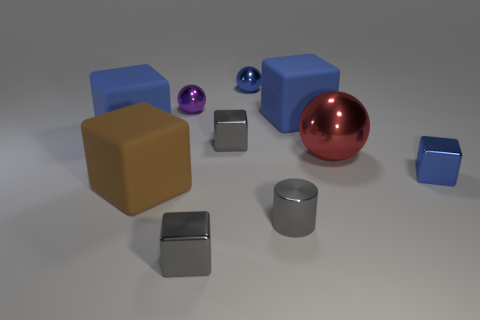Subtract all gray cubes. How many cubes are left? 4 Subtract all cylinders. How many objects are left? 9 Subtract all blue cubes. How many cubes are left? 3 Subtract all red shiny objects. Subtract all tiny metal blocks. How many objects are left? 6 Add 4 blue blocks. How many blue blocks are left? 7 Add 2 red metal balls. How many red metal balls exist? 3 Subtract 0 yellow spheres. How many objects are left? 10 Subtract 3 cubes. How many cubes are left? 3 Subtract all red balls. Subtract all cyan blocks. How many balls are left? 2 Subtract all red balls. How many gray cubes are left? 2 